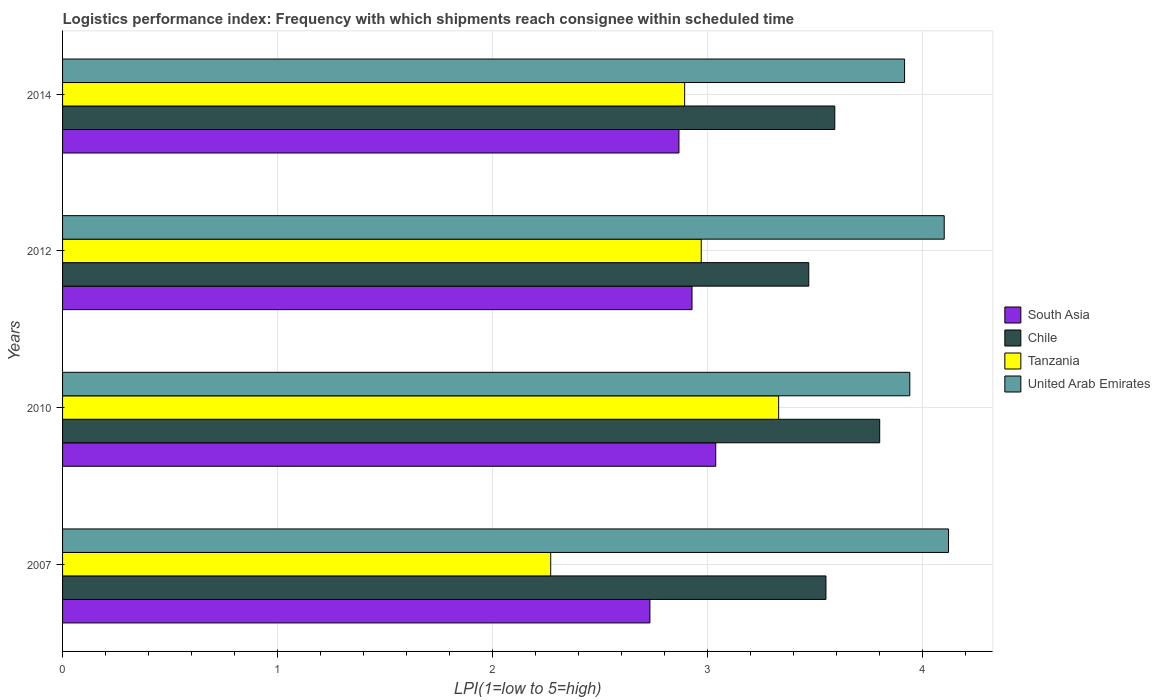Are the number of bars per tick equal to the number of legend labels?
Your answer should be compact. Yes. What is the label of the 4th group of bars from the top?
Keep it short and to the point. 2007. What is the logistics performance index in Tanzania in 2007?
Provide a succinct answer. 2.27. Across all years, what is the maximum logistics performance index in United Arab Emirates?
Your answer should be very brief. 4.12. Across all years, what is the minimum logistics performance index in United Arab Emirates?
Your answer should be very brief. 3.92. In which year was the logistics performance index in South Asia minimum?
Provide a short and direct response. 2007. What is the total logistics performance index in Tanzania in the graph?
Make the answer very short. 11.46. What is the difference between the logistics performance index in Tanzania in 2010 and that in 2012?
Provide a succinct answer. 0.36. What is the difference between the logistics performance index in Tanzania in 2010 and the logistics performance index in Chile in 2012?
Keep it short and to the point. -0.14. What is the average logistics performance index in South Asia per year?
Your answer should be compact. 2.89. In the year 2007, what is the difference between the logistics performance index in South Asia and logistics performance index in Tanzania?
Offer a very short reply. 0.46. What is the ratio of the logistics performance index in South Asia in 2012 to that in 2014?
Offer a terse response. 1.02. Is the logistics performance index in Tanzania in 2007 less than that in 2012?
Give a very brief answer. Yes. Is the difference between the logistics performance index in South Asia in 2010 and 2012 greater than the difference between the logistics performance index in Tanzania in 2010 and 2012?
Ensure brevity in your answer.  No. What is the difference between the highest and the second highest logistics performance index in Tanzania?
Keep it short and to the point. 0.36. What is the difference between the highest and the lowest logistics performance index in South Asia?
Offer a terse response. 0.31. Is the sum of the logistics performance index in South Asia in 2010 and 2012 greater than the maximum logistics performance index in Tanzania across all years?
Your answer should be compact. Yes. What does the 2nd bar from the bottom in 2014 represents?
Provide a succinct answer. Chile. Is it the case that in every year, the sum of the logistics performance index in South Asia and logistics performance index in Chile is greater than the logistics performance index in United Arab Emirates?
Keep it short and to the point. Yes. How many bars are there?
Your answer should be very brief. 16. Are all the bars in the graph horizontal?
Make the answer very short. Yes. Does the graph contain grids?
Give a very brief answer. Yes. Where does the legend appear in the graph?
Offer a terse response. Center right. How are the legend labels stacked?
Keep it short and to the point. Vertical. What is the title of the graph?
Your answer should be compact. Logistics performance index: Frequency with which shipments reach consignee within scheduled time. What is the label or title of the X-axis?
Provide a succinct answer. LPI(1=low to 5=high). What is the LPI(1=low to 5=high) of South Asia in 2007?
Your answer should be compact. 2.73. What is the LPI(1=low to 5=high) of Chile in 2007?
Offer a terse response. 3.55. What is the LPI(1=low to 5=high) in Tanzania in 2007?
Make the answer very short. 2.27. What is the LPI(1=low to 5=high) of United Arab Emirates in 2007?
Give a very brief answer. 4.12. What is the LPI(1=low to 5=high) of South Asia in 2010?
Your answer should be compact. 3.04. What is the LPI(1=low to 5=high) of Chile in 2010?
Your response must be concise. 3.8. What is the LPI(1=low to 5=high) in Tanzania in 2010?
Offer a very short reply. 3.33. What is the LPI(1=low to 5=high) in United Arab Emirates in 2010?
Provide a succinct answer. 3.94. What is the LPI(1=low to 5=high) in South Asia in 2012?
Your answer should be compact. 2.93. What is the LPI(1=low to 5=high) in Chile in 2012?
Keep it short and to the point. 3.47. What is the LPI(1=low to 5=high) in Tanzania in 2012?
Give a very brief answer. 2.97. What is the LPI(1=low to 5=high) of United Arab Emirates in 2012?
Give a very brief answer. 4.1. What is the LPI(1=low to 5=high) in South Asia in 2014?
Offer a terse response. 2.87. What is the LPI(1=low to 5=high) in Chile in 2014?
Provide a succinct answer. 3.59. What is the LPI(1=low to 5=high) of Tanzania in 2014?
Offer a very short reply. 2.89. What is the LPI(1=low to 5=high) in United Arab Emirates in 2014?
Ensure brevity in your answer.  3.92. Across all years, what is the maximum LPI(1=low to 5=high) in South Asia?
Your answer should be very brief. 3.04. Across all years, what is the maximum LPI(1=low to 5=high) of Chile?
Offer a terse response. 3.8. Across all years, what is the maximum LPI(1=low to 5=high) of Tanzania?
Your response must be concise. 3.33. Across all years, what is the maximum LPI(1=low to 5=high) in United Arab Emirates?
Offer a terse response. 4.12. Across all years, what is the minimum LPI(1=low to 5=high) in South Asia?
Keep it short and to the point. 2.73. Across all years, what is the minimum LPI(1=low to 5=high) in Chile?
Your answer should be compact. 3.47. Across all years, what is the minimum LPI(1=low to 5=high) of Tanzania?
Provide a succinct answer. 2.27. Across all years, what is the minimum LPI(1=low to 5=high) in United Arab Emirates?
Offer a terse response. 3.92. What is the total LPI(1=low to 5=high) of South Asia in the graph?
Your response must be concise. 11.56. What is the total LPI(1=low to 5=high) in Chile in the graph?
Your response must be concise. 14.41. What is the total LPI(1=low to 5=high) in Tanzania in the graph?
Your answer should be very brief. 11.46. What is the total LPI(1=low to 5=high) in United Arab Emirates in the graph?
Offer a terse response. 16.08. What is the difference between the LPI(1=low to 5=high) in South Asia in 2007 and that in 2010?
Provide a short and direct response. -0.31. What is the difference between the LPI(1=low to 5=high) in Tanzania in 2007 and that in 2010?
Offer a very short reply. -1.06. What is the difference between the LPI(1=low to 5=high) of United Arab Emirates in 2007 and that in 2010?
Your answer should be compact. 0.18. What is the difference between the LPI(1=low to 5=high) of South Asia in 2007 and that in 2012?
Your answer should be compact. -0.2. What is the difference between the LPI(1=low to 5=high) of Chile in 2007 and that in 2012?
Provide a succinct answer. 0.08. What is the difference between the LPI(1=low to 5=high) in South Asia in 2007 and that in 2014?
Give a very brief answer. -0.14. What is the difference between the LPI(1=low to 5=high) of Chile in 2007 and that in 2014?
Give a very brief answer. -0.04. What is the difference between the LPI(1=low to 5=high) of Tanzania in 2007 and that in 2014?
Ensure brevity in your answer.  -0.62. What is the difference between the LPI(1=low to 5=high) of United Arab Emirates in 2007 and that in 2014?
Provide a succinct answer. 0.2. What is the difference between the LPI(1=low to 5=high) in South Asia in 2010 and that in 2012?
Your response must be concise. 0.11. What is the difference between the LPI(1=low to 5=high) of Chile in 2010 and that in 2012?
Ensure brevity in your answer.  0.33. What is the difference between the LPI(1=low to 5=high) of Tanzania in 2010 and that in 2012?
Keep it short and to the point. 0.36. What is the difference between the LPI(1=low to 5=high) in United Arab Emirates in 2010 and that in 2012?
Your response must be concise. -0.16. What is the difference between the LPI(1=low to 5=high) in South Asia in 2010 and that in 2014?
Offer a very short reply. 0.17. What is the difference between the LPI(1=low to 5=high) in Chile in 2010 and that in 2014?
Your response must be concise. 0.21. What is the difference between the LPI(1=low to 5=high) of Tanzania in 2010 and that in 2014?
Make the answer very short. 0.44. What is the difference between the LPI(1=low to 5=high) of United Arab Emirates in 2010 and that in 2014?
Give a very brief answer. 0.02. What is the difference between the LPI(1=low to 5=high) of South Asia in 2012 and that in 2014?
Make the answer very short. 0.06. What is the difference between the LPI(1=low to 5=high) in Chile in 2012 and that in 2014?
Offer a very short reply. -0.12. What is the difference between the LPI(1=low to 5=high) of Tanzania in 2012 and that in 2014?
Ensure brevity in your answer.  0.08. What is the difference between the LPI(1=low to 5=high) of United Arab Emirates in 2012 and that in 2014?
Keep it short and to the point. 0.18. What is the difference between the LPI(1=low to 5=high) of South Asia in 2007 and the LPI(1=low to 5=high) of Chile in 2010?
Make the answer very short. -1.07. What is the difference between the LPI(1=low to 5=high) of South Asia in 2007 and the LPI(1=low to 5=high) of Tanzania in 2010?
Your answer should be very brief. -0.6. What is the difference between the LPI(1=low to 5=high) in South Asia in 2007 and the LPI(1=low to 5=high) in United Arab Emirates in 2010?
Provide a short and direct response. -1.21. What is the difference between the LPI(1=low to 5=high) of Chile in 2007 and the LPI(1=low to 5=high) of Tanzania in 2010?
Your answer should be very brief. 0.22. What is the difference between the LPI(1=low to 5=high) in Chile in 2007 and the LPI(1=low to 5=high) in United Arab Emirates in 2010?
Your answer should be very brief. -0.39. What is the difference between the LPI(1=low to 5=high) in Tanzania in 2007 and the LPI(1=low to 5=high) in United Arab Emirates in 2010?
Your answer should be compact. -1.67. What is the difference between the LPI(1=low to 5=high) of South Asia in 2007 and the LPI(1=low to 5=high) of Chile in 2012?
Provide a succinct answer. -0.74. What is the difference between the LPI(1=low to 5=high) in South Asia in 2007 and the LPI(1=low to 5=high) in Tanzania in 2012?
Make the answer very short. -0.24. What is the difference between the LPI(1=low to 5=high) of South Asia in 2007 and the LPI(1=low to 5=high) of United Arab Emirates in 2012?
Give a very brief answer. -1.37. What is the difference between the LPI(1=low to 5=high) of Chile in 2007 and the LPI(1=low to 5=high) of Tanzania in 2012?
Offer a very short reply. 0.58. What is the difference between the LPI(1=low to 5=high) of Chile in 2007 and the LPI(1=low to 5=high) of United Arab Emirates in 2012?
Offer a terse response. -0.55. What is the difference between the LPI(1=low to 5=high) of Tanzania in 2007 and the LPI(1=low to 5=high) of United Arab Emirates in 2012?
Your answer should be compact. -1.83. What is the difference between the LPI(1=low to 5=high) in South Asia in 2007 and the LPI(1=low to 5=high) in Chile in 2014?
Give a very brief answer. -0.86. What is the difference between the LPI(1=low to 5=high) of South Asia in 2007 and the LPI(1=low to 5=high) of Tanzania in 2014?
Provide a succinct answer. -0.16. What is the difference between the LPI(1=low to 5=high) in South Asia in 2007 and the LPI(1=low to 5=high) in United Arab Emirates in 2014?
Your answer should be very brief. -1.18. What is the difference between the LPI(1=low to 5=high) in Chile in 2007 and the LPI(1=low to 5=high) in Tanzania in 2014?
Your answer should be very brief. 0.66. What is the difference between the LPI(1=low to 5=high) in Chile in 2007 and the LPI(1=low to 5=high) in United Arab Emirates in 2014?
Ensure brevity in your answer.  -0.37. What is the difference between the LPI(1=low to 5=high) in Tanzania in 2007 and the LPI(1=low to 5=high) in United Arab Emirates in 2014?
Keep it short and to the point. -1.65. What is the difference between the LPI(1=low to 5=high) of South Asia in 2010 and the LPI(1=low to 5=high) of Chile in 2012?
Make the answer very short. -0.43. What is the difference between the LPI(1=low to 5=high) in South Asia in 2010 and the LPI(1=low to 5=high) in Tanzania in 2012?
Your answer should be compact. 0.07. What is the difference between the LPI(1=low to 5=high) in South Asia in 2010 and the LPI(1=low to 5=high) in United Arab Emirates in 2012?
Keep it short and to the point. -1.06. What is the difference between the LPI(1=low to 5=high) in Chile in 2010 and the LPI(1=low to 5=high) in Tanzania in 2012?
Make the answer very short. 0.83. What is the difference between the LPI(1=low to 5=high) in Chile in 2010 and the LPI(1=low to 5=high) in United Arab Emirates in 2012?
Provide a short and direct response. -0.3. What is the difference between the LPI(1=low to 5=high) of Tanzania in 2010 and the LPI(1=low to 5=high) of United Arab Emirates in 2012?
Give a very brief answer. -0.77. What is the difference between the LPI(1=low to 5=high) in South Asia in 2010 and the LPI(1=low to 5=high) in Chile in 2014?
Provide a succinct answer. -0.55. What is the difference between the LPI(1=low to 5=high) of South Asia in 2010 and the LPI(1=low to 5=high) of Tanzania in 2014?
Provide a short and direct response. 0.14. What is the difference between the LPI(1=low to 5=high) in South Asia in 2010 and the LPI(1=low to 5=high) in United Arab Emirates in 2014?
Your answer should be very brief. -0.88. What is the difference between the LPI(1=low to 5=high) of Chile in 2010 and the LPI(1=low to 5=high) of Tanzania in 2014?
Provide a succinct answer. 0.91. What is the difference between the LPI(1=low to 5=high) in Chile in 2010 and the LPI(1=low to 5=high) in United Arab Emirates in 2014?
Offer a very short reply. -0.12. What is the difference between the LPI(1=low to 5=high) of Tanzania in 2010 and the LPI(1=low to 5=high) of United Arab Emirates in 2014?
Your answer should be compact. -0.59. What is the difference between the LPI(1=low to 5=high) in South Asia in 2012 and the LPI(1=low to 5=high) in Chile in 2014?
Provide a short and direct response. -0.66. What is the difference between the LPI(1=low to 5=high) in South Asia in 2012 and the LPI(1=low to 5=high) in Tanzania in 2014?
Provide a short and direct response. 0.03. What is the difference between the LPI(1=low to 5=high) in South Asia in 2012 and the LPI(1=low to 5=high) in United Arab Emirates in 2014?
Your response must be concise. -0.99. What is the difference between the LPI(1=low to 5=high) in Chile in 2012 and the LPI(1=low to 5=high) in Tanzania in 2014?
Offer a very short reply. 0.58. What is the difference between the LPI(1=low to 5=high) of Chile in 2012 and the LPI(1=low to 5=high) of United Arab Emirates in 2014?
Your answer should be very brief. -0.45. What is the difference between the LPI(1=low to 5=high) in Tanzania in 2012 and the LPI(1=low to 5=high) in United Arab Emirates in 2014?
Your answer should be compact. -0.95. What is the average LPI(1=low to 5=high) in South Asia per year?
Offer a terse response. 2.89. What is the average LPI(1=low to 5=high) in Chile per year?
Provide a succinct answer. 3.6. What is the average LPI(1=low to 5=high) in Tanzania per year?
Keep it short and to the point. 2.87. What is the average LPI(1=low to 5=high) of United Arab Emirates per year?
Give a very brief answer. 4.02. In the year 2007, what is the difference between the LPI(1=low to 5=high) in South Asia and LPI(1=low to 5=high) in Chile?
Offer a terse response. -0.82. In the year 2007, what is the difference between the LPI(1=low to 5=high) of South Asia and LPI(1=low to 5=high) of Tanzania?
Your answer should be compact. 0.46. In the year 2007, what is the difference between the LPI(1=low to 5=high) of South Asia and LPI(1=low to 5=high) of United Arab Emirates?
Your answer should be compact. -1.39. In the year 2007, what is the difference between the LPI(1=low to 5=high) of Chile and LPI(1=low to 5=high) of Tanzania?
Ensure brevity in your answer.  1.28. In the year 2007, what is the difference between the LPI(1=low to 5=high) of Chile and LPI(1=low to 5=high) of United Arab Emirates?
Provide a succinct answer. -0.57. In the year 2007, what is the difference between the LPI(1=low to 5=high) of Tanzania and LPI(1=low to 5=high) of United Arab Emirates?
Provide a short and direct response. -1.85. In the year 2010, what is the difference between the LPI(1=low to 5=high) of South Asia and LPI(1=low to 5=high) of Chile?
Provide a short and direct response. -0.76. In the year 2010, what is the difference between the LPI(1=low to 5=high) of South Asia and LPI(1=low to 5=high) of Tanzania?
Offer a terse response. -0.29. In the year 2010, what is the difference between the LPI(1=low to 5=high) of South Asia and LPI(1=low to 5=high) of United Arab Emirates?
Give a very brief answer. -0.9. In the year 2010, what is the difference between the LPI(1=low to 5=high) in Chile and LPI(1=low to 5=high) in Tanzania?
Provide a short and direct response. 0.47. In the year 2010, what is the difference between the LPI(1=low to 5=high) in Chile and LPI(1=low to 5=high) in United Arab Emirates?
Give a very brief answer. -0.14. In the year 2010, what is the difference between the LPI(1=low to 5=high) in Tanzania and LPI(1=low to 5=high) in United Arab Emirates?
Provide a succinct answer. -0.61. In the year 2012, what is the difference between the LPI(1=low to 5=high) in South Asia and LPI(1=low to 5=high) in Chile?
Offer a terse response. -0.54. In the year 2012, what is the difference between the LPI(1=low to 5=high) in South Asia and LPI(1=low to 5=high) in Tanzania?
Your answer should be compact. -0.04. In the year 2012, what is the difference between the LPI(1=low to 5=high) in South Asia and LPI(1=low to 5=high) in United Arab Emirates?
Your answer should be very brief. -1.17. In the year 2012, what is the difference between the LPI(1=low to 5=high) in Chile and LPI(1=low to 5=high) in Tanzania?
Give a very brief answer. 0.5. In the year 2012, what is the difference between the LPI(1=low to 5=high) in Chile and LPI(1=low to 5=high) in United Arab Emirates?
Your answer should be compact. -0.63. In the year 2012, what is the difference between the LPI(1=low to 5=high) in Tanzania and LPI(1=low to 5=high) in United Arab Emirates?
Your response must be concise. -1.13. In the year 2014, what is the difference between the LPI(1=low to 5=high) of South Asia and LPI(1=low to 5=high) of Chile?
Your response must be concise. -0.72. In the year 2014, what is the difference between the LPI(1=low to 5=high) of South Asia and LPI(1=low to 5=high) of Tanzania?
Make the answer very short. -0.03. In the year 2014, what is the difference between the LPI(1=low to 5=high) in South Asia and LPI(1=low to 5=high) in United Arab Emirates?
Offer a very short reply. -1.05. In the year 2014, what is the difference between the LPI(1=low to 5=high) in Chile and LPI(1=low to 5=high) in Tanzania?
Your answer should be very brief. 0.7. In the year 2014, what is the difference between the LPI(1=low to 5=high) in Chile and LPI(1=low to 5=high) in United Arab Emirates?
Ensure brevity in your answer.  -0.32. In the year 2014, what is the difference between the LPI(1=low to 5=high) in Tanzania and LPI(1=low to 5=high) in United Arab Emirates?
Your answer should be very brief. -1.02. What is the ratio of the LPI(1=low to 5=high) in South Asia in 2007 to that in 2010?
Your response must be concise. 0.9. What is the ratio of the LPI(1=low to 5=high) in Chile in 2007 to that in 2010?
Offer a terse response. 0.93. What is the ratio of the LPI(1=low to 5=high) of Tanzania in 2007 to that in 2010?
Your answer should be very brief. 0.68. What is the ratio of the LPI(1=low to 5=high) in United Arab Emirates in 2007 to that in 2010?
Your answer should be compact. 1.05. What is the ratio of the LPI(1=low to 5=high) in South Asia in 2007 to that in 2012?
Your answer should be compact. 0.93. What is the ratio of the LPI(1=low to 5=high) of Chile in 2007 to that in 2012?
Give a very brief answer. 1.02. What is the ratio of the LPI(1=low to 5=high) in Tanzania in 2007 to that in 2012?
Your answer should be compact. 0.76. What is the ratio of the LPI(1=low to 5=high) in South Asia in 2007 to that in 2014?
Your answer should be compact. 0.95. What is the ratio of the LPI(1=low to 5=high) in Chile in 2007 to that in 2014?
Your answer should be very brief. 0.99. What is the ratio of the LPI(1=low to 5=high) of Tanzania in 2007 to that in 2014?
Give a very brief answer. 0.78. What is the ratio of the LPI(1=low to 5=high) of United Arab Emirates in 2007 to that in 2014?
Provide a short and direct response. 1.05. What is the ratio of the LPI(1=low to 5=high) in South Asia in 2010 to that in 2012?
Make the answer very short. 1.04. What is the ratio of the LPI(1=low to 5=high) of Chile in 2010 to that in 2012?
Make the answer very short. 1.1. What is the ratio of the LPI(1=low to 5=high) in Tanzania in 2010 to that in 2012?
Give a very brief answer. 1.12. What is the ratio of the LPI(1=low to 5=high) in United Arab Emirates in 2010 to that in 2012?
Offer a terse response. 0.96. What is the ratio of the LPI(1=low to 5=high) in South Asia in 2010 to that in 2014?
Ensure brevity in your answer.  1.06. What is the ratio of the LPI(1=low to 5=high) of Chile in 2010 to that in 2014?
Offer a terse response. 1.06. What is the ratio of the LPI(1=low to 5=high) in Tanzania in 2010 to that in 2014?
Offer a terse response. 1.15. What is the ratio of the LPI(1=low to 5=high) in United Arab Emirates in 2010 to that in 2014?
Ensure brevity in your answer.  1.01. What is the ratio of the LPI(1=low to 5=high) in South Asia in 2012 to that in 2014?
Give a very brief answer. 1.02. What is the ratio of the LPI(1=low to 5=high) of Chile in 2012 to that in 2014?
Your answer should be compact. 0.97. What is the ratio of the LPI(1=low to 5=high) in Tanzania in 2012 to that in 2014?
Your answer should be compact. 1.03. What is the ratio of the LPI(1=low to 5=high) of United Arab Emirates in 2012 to that in 2014?
Provide a short and direct response. 1.05. What is the difference between the highest and the second highest LPI(1=low to 5=high) of South Asia?
Give a very brief answer. 0.11. What is the difference between the highest and the second highest LPI(1=low to 5=high) in Chile?
Ensure brevity in your answer.  0.21. What is the difference between the highest and the second highest LPI(1=low to 5=high) of Tanzania?
Your answer should be very brief. 0.36. What is the difference between the highest and the second highest LPI(1=low to 5=high) in United Arab Emirates?
Your response must be concise. 0.02. What is the difference between the highest and the lowest LPI(1=low to 5=high) in South Asia?
Your response must be concise. 0.31. What is the difference between the highest and the lowest LPI(1=low to 5=high) in Chile?
Give a very brief answer. 0.33. What is the difference between the highest and the lowest LPI(1=low to 5=high) in Tanzania?
Your answer should be very brief. 1.06. What is the difference between the highest and the lowest LPI(1=low to 5=high) in United Arab Emirates?
Offer a very short reply. 0.2. 